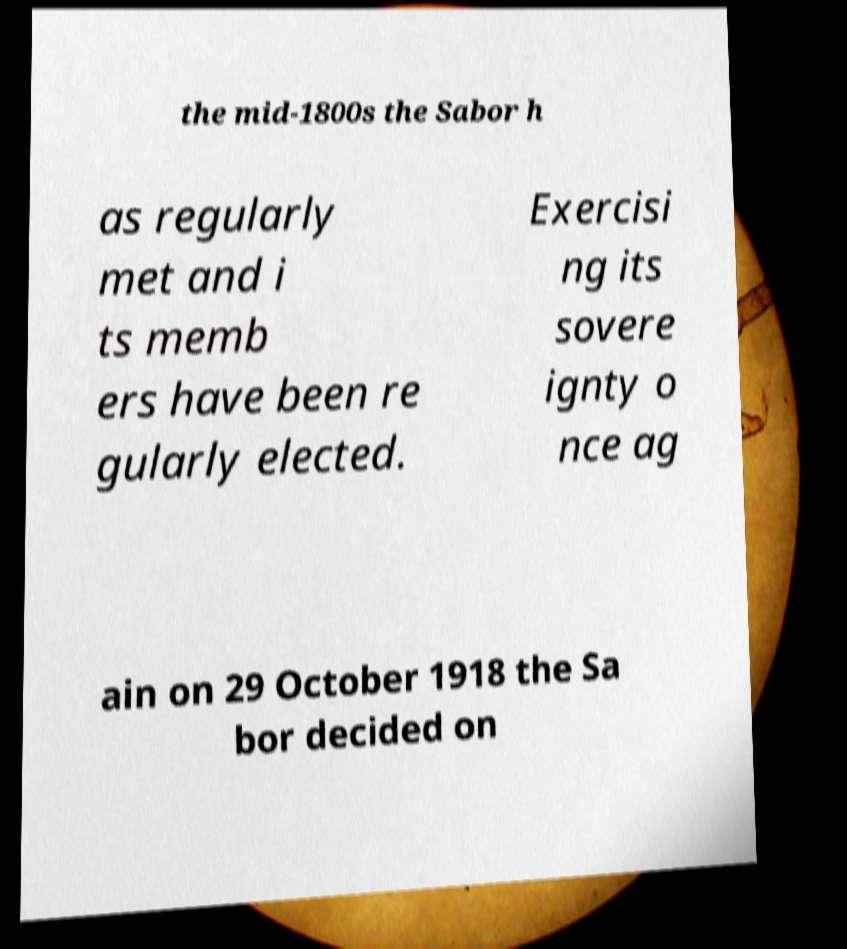For documentation purposes, I need the text within this image transcribed. Could you provide that? the mid-1800s the Sabor h as regularly met and i ts memb ers have been re gularly elected. Exercisi ng its sovere ignty o nce ag ain on 29 October 1918 the Sa bor decided on 